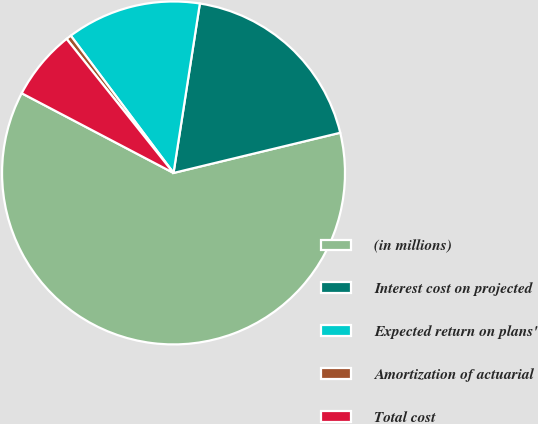Convert chart. <chart><loc_0><loc_0><loc_500><loc_500><pie_chart><fcel>(in millions)<fcel>Interest cost on projected<fcel>Expected return on plans'<fcel>Amortization of actuarial<fcel>Total cost<nl><fcel>61.46%<fcel>18.78%<fcel>12.68%<fcel>0.49%<fcel>6.59%<nl></chart> 